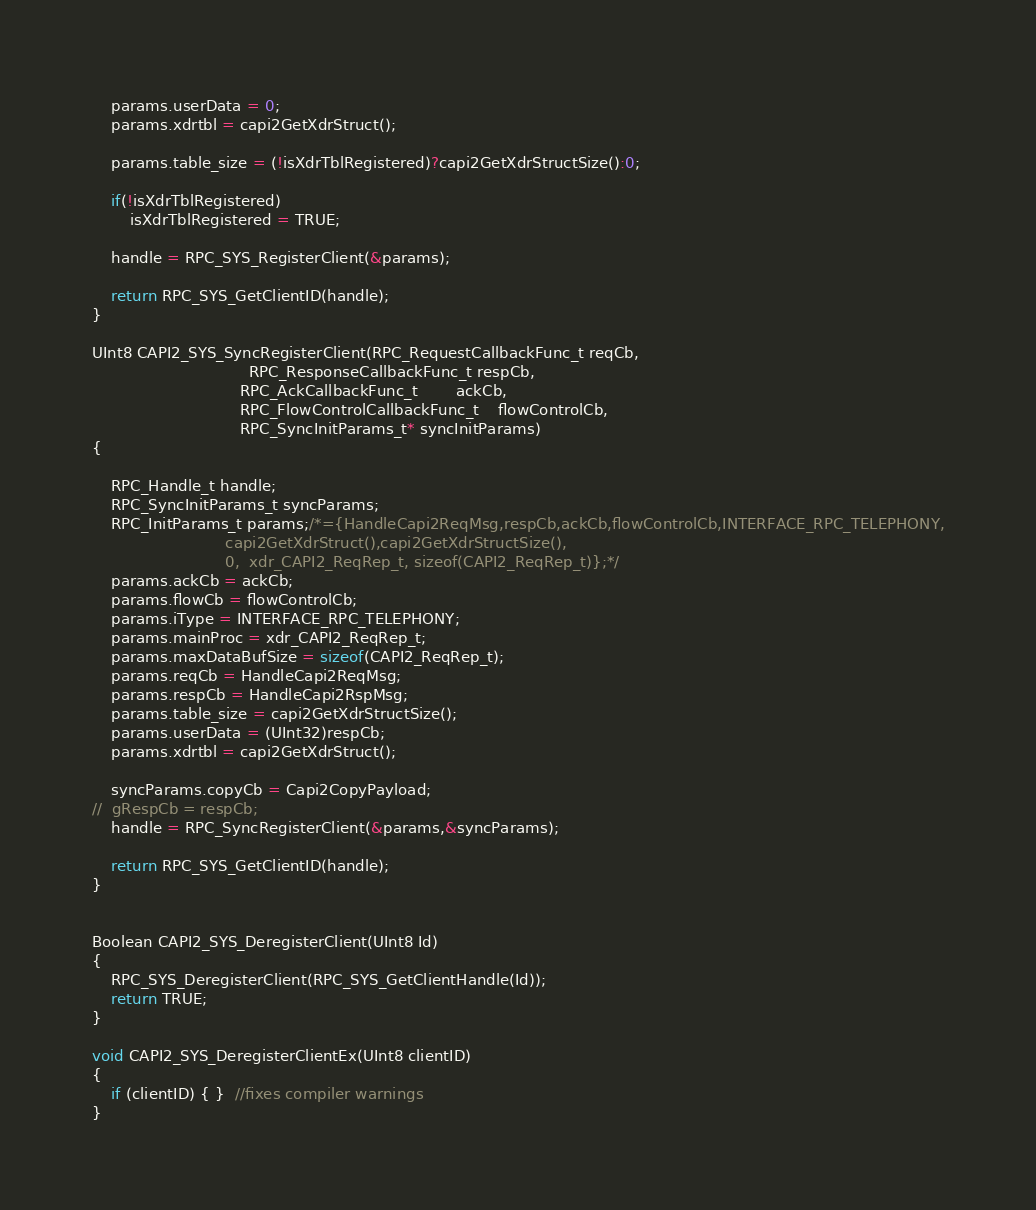Convert code to text. <code><loc_0><loc_0><loc_500><loc_500><_C_>	params.userData = 0;
	params.xdrtbl = capi2GetXdrStruct();
	
	params.table_size = (!isXdrTblRegistered)?capi2GetXdrStructSize():0;

	if(!isXdrTblRegistered)
		isXdrTblRegistered = TRUE;

	handle = RPC_SYS_RegisterClient(&params);

	return RPC_SYS_GetClientID(handle);
}

UInt8 CAPI2_SYS_SyncRegisterClient(RPC_RequestCallbackFunc_t reqCb,
								 RPC_ResponseCallbackFunc_t respCb, 
							   RPC_AckCallbackFunc_t		ackCb,
							   RPC_FlowControlCallbackFunc_t	flowControlCb, 
							   RPC_SyncInitParams_t* syncInitParams)
{

	RPC_Handle_t handle;
	RPC_SyncInitParams_t syncParams;
	RPC_InitParams_t params;/*={HandleCapi2ReqMsg,respCb,ackCb,flowControlCb,INTERFACE_RPC_TELEPHONY,
							capi2GetXdrStruct(),capi2GetXdrStructSize(),
							0, 	xdr_CAPI2_ReqRep_t, sizeof(CAPI2_ReqRep_t)};*/
	params.ackCb = ackCb;
	params.flowCb = flowControlCb;
	params.iType = INTERFACE_RPC_TELEPHONY;
	params.mainProc = xdr_CAPI2_ReqRep_t;
	params.maxDataBufSize = sizeof(CAPI2_ReqRep_t);
	params.reqCb = HandleCapi2ReqMsg;
	params.respCb = HandleCapi2RspMsg;
	params.table_size = capi2GetXdrStructSize();
	params.userData = (UInt32)respCb;
	params.xdrtbl = capi2GetXdrStruct();

	syncParams.copyCb = Capi2CopyPayload;
//	gRespCb = respCb;
	handle = RPC_SyncRegisterClient(&params,&syncParams);

	return RPC_SYS_GetClientID(handle);
}


Boolean CAPI2_SYS_DeregisterClient(UInt8 Id)
{
	RPC_SYS_DeregisterClient(RPC_SYS_GetClientHandle(Id));
	return TRUE;
}

void CAPI2_SYS_DeregisterClientEx(UInt8 clientID)
{
	if (clientID) { }  //fixes compiler warnings
}

</code> 